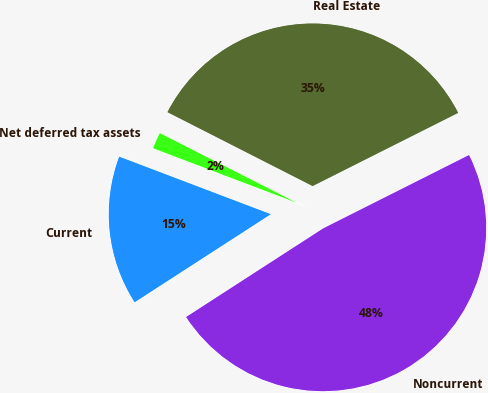Convert chart. <chart><loc_0><loc_0><loc_500><loc_500><pie_chart><fcel>Current<fcel>Noncurrent<fcel>Real Estate<fcel>Net deferred tax assets<nl><fcel>14.91%<fcel>48.28%<fcel>35.09%<fcel>1.72%<nl></chart> 